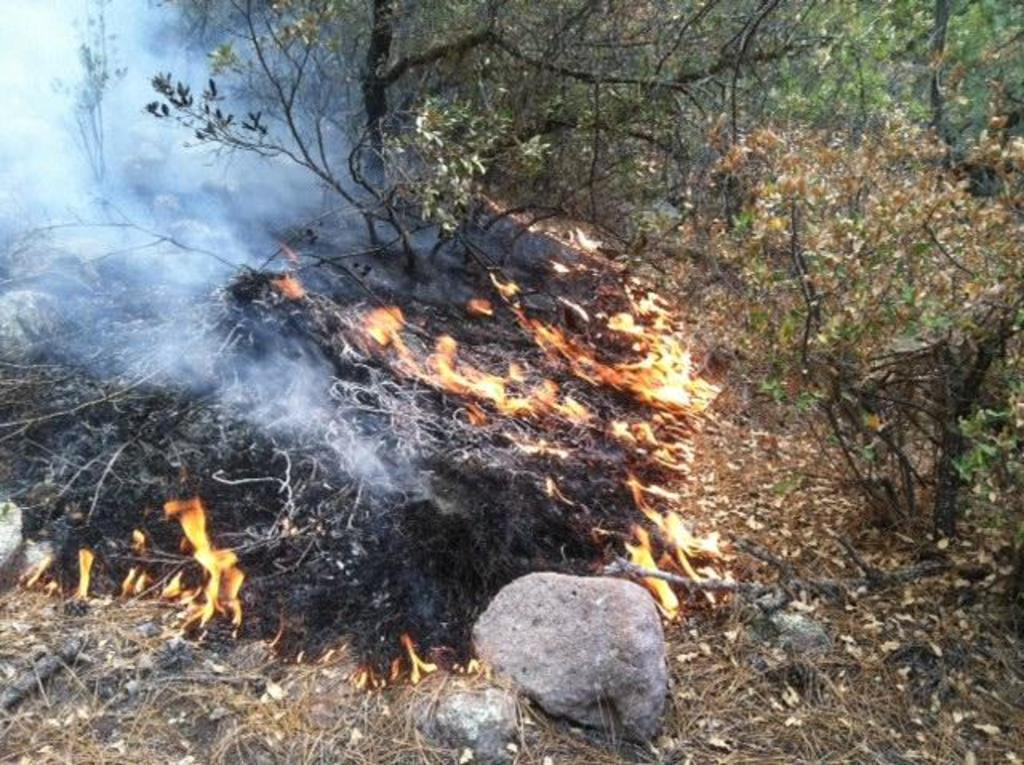What is happening to the plants in the image? The plants are burning in the image. What type of vegetation can be seen in the image besides the burning plants? There are trees and other plants in the image. What else is present in the image besides vegetation? There are rocks in the image. What does the burning plant taste like in the image? There is no indication in the image that the burning plants can be tasted, and therefore it cannot be determined from the picture. 